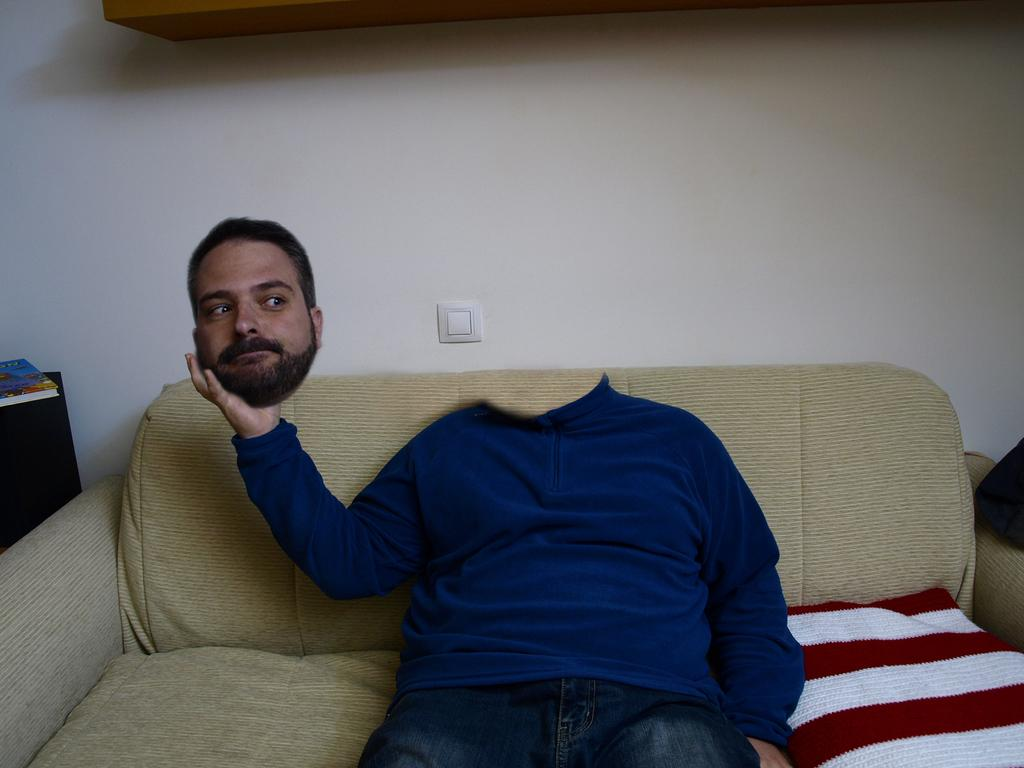What is the man in the image doing? The man is sitting in the sofa. How is the man positioned on the sofa? The man has his head placed in his hand. What color is the blanket on the sofa? The blanket on the sofa is red. What can be seen in the background of the image? There is a wall in the background of the image. What time of day is it in the image, given the presence of sleet? There is no mention of sleet in the image, and therefore we cannot determine the time of day based on that information. 